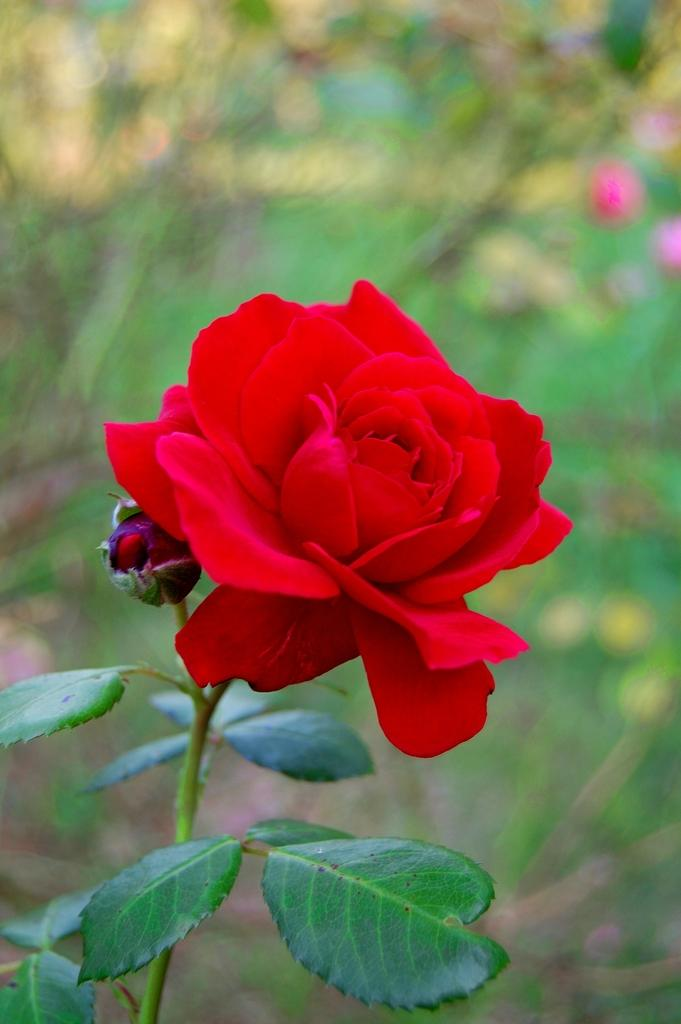What type of flower is in the image? There is a rose flower in the image. Can you describe any specific features of the rose flower? The rose flower has a bud on the stem. What event is being taught in the image? There is no event or teaching depicted in the image; it only features a rose flower with a bud on the stem. 